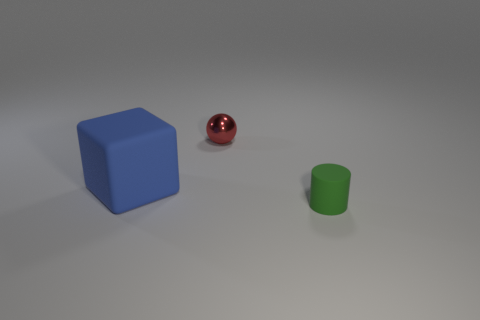Are there the same number of red metal spheres behind the small shiny ball and large blue matte objects?
Ensure brevity in your answer.  No. There is a matte thing left of the red object; does it have the same size as the green rubber cylinder?
Keep it short and to the point. No. How many green cylinders are on the left side of the large blue block?
Ensure brevity in your answer.  0. There is a thing that is behind the matte cylinder and to the right of the matte cube; what is its material?
Your answer should be compact. Metal. What number of big things are either blue cubes or green rubber spheres?
Make the answer very short. 1. What size is the blue thing?
Give a very brief answer. Large. What is the shape of the small red object?
Offer a very short reply. Sphere. Are there any other things that have the same shape as the large blue rubber thing?
Ensure brevity in your answer.  No. Are there fewer things that are to the left of the tiny red ball than tiny green rubber objects?
Ensure brevity in your answer.  No. How many matte things are yellow cylinders or blue things?
Provide a short and direct response. 1. 